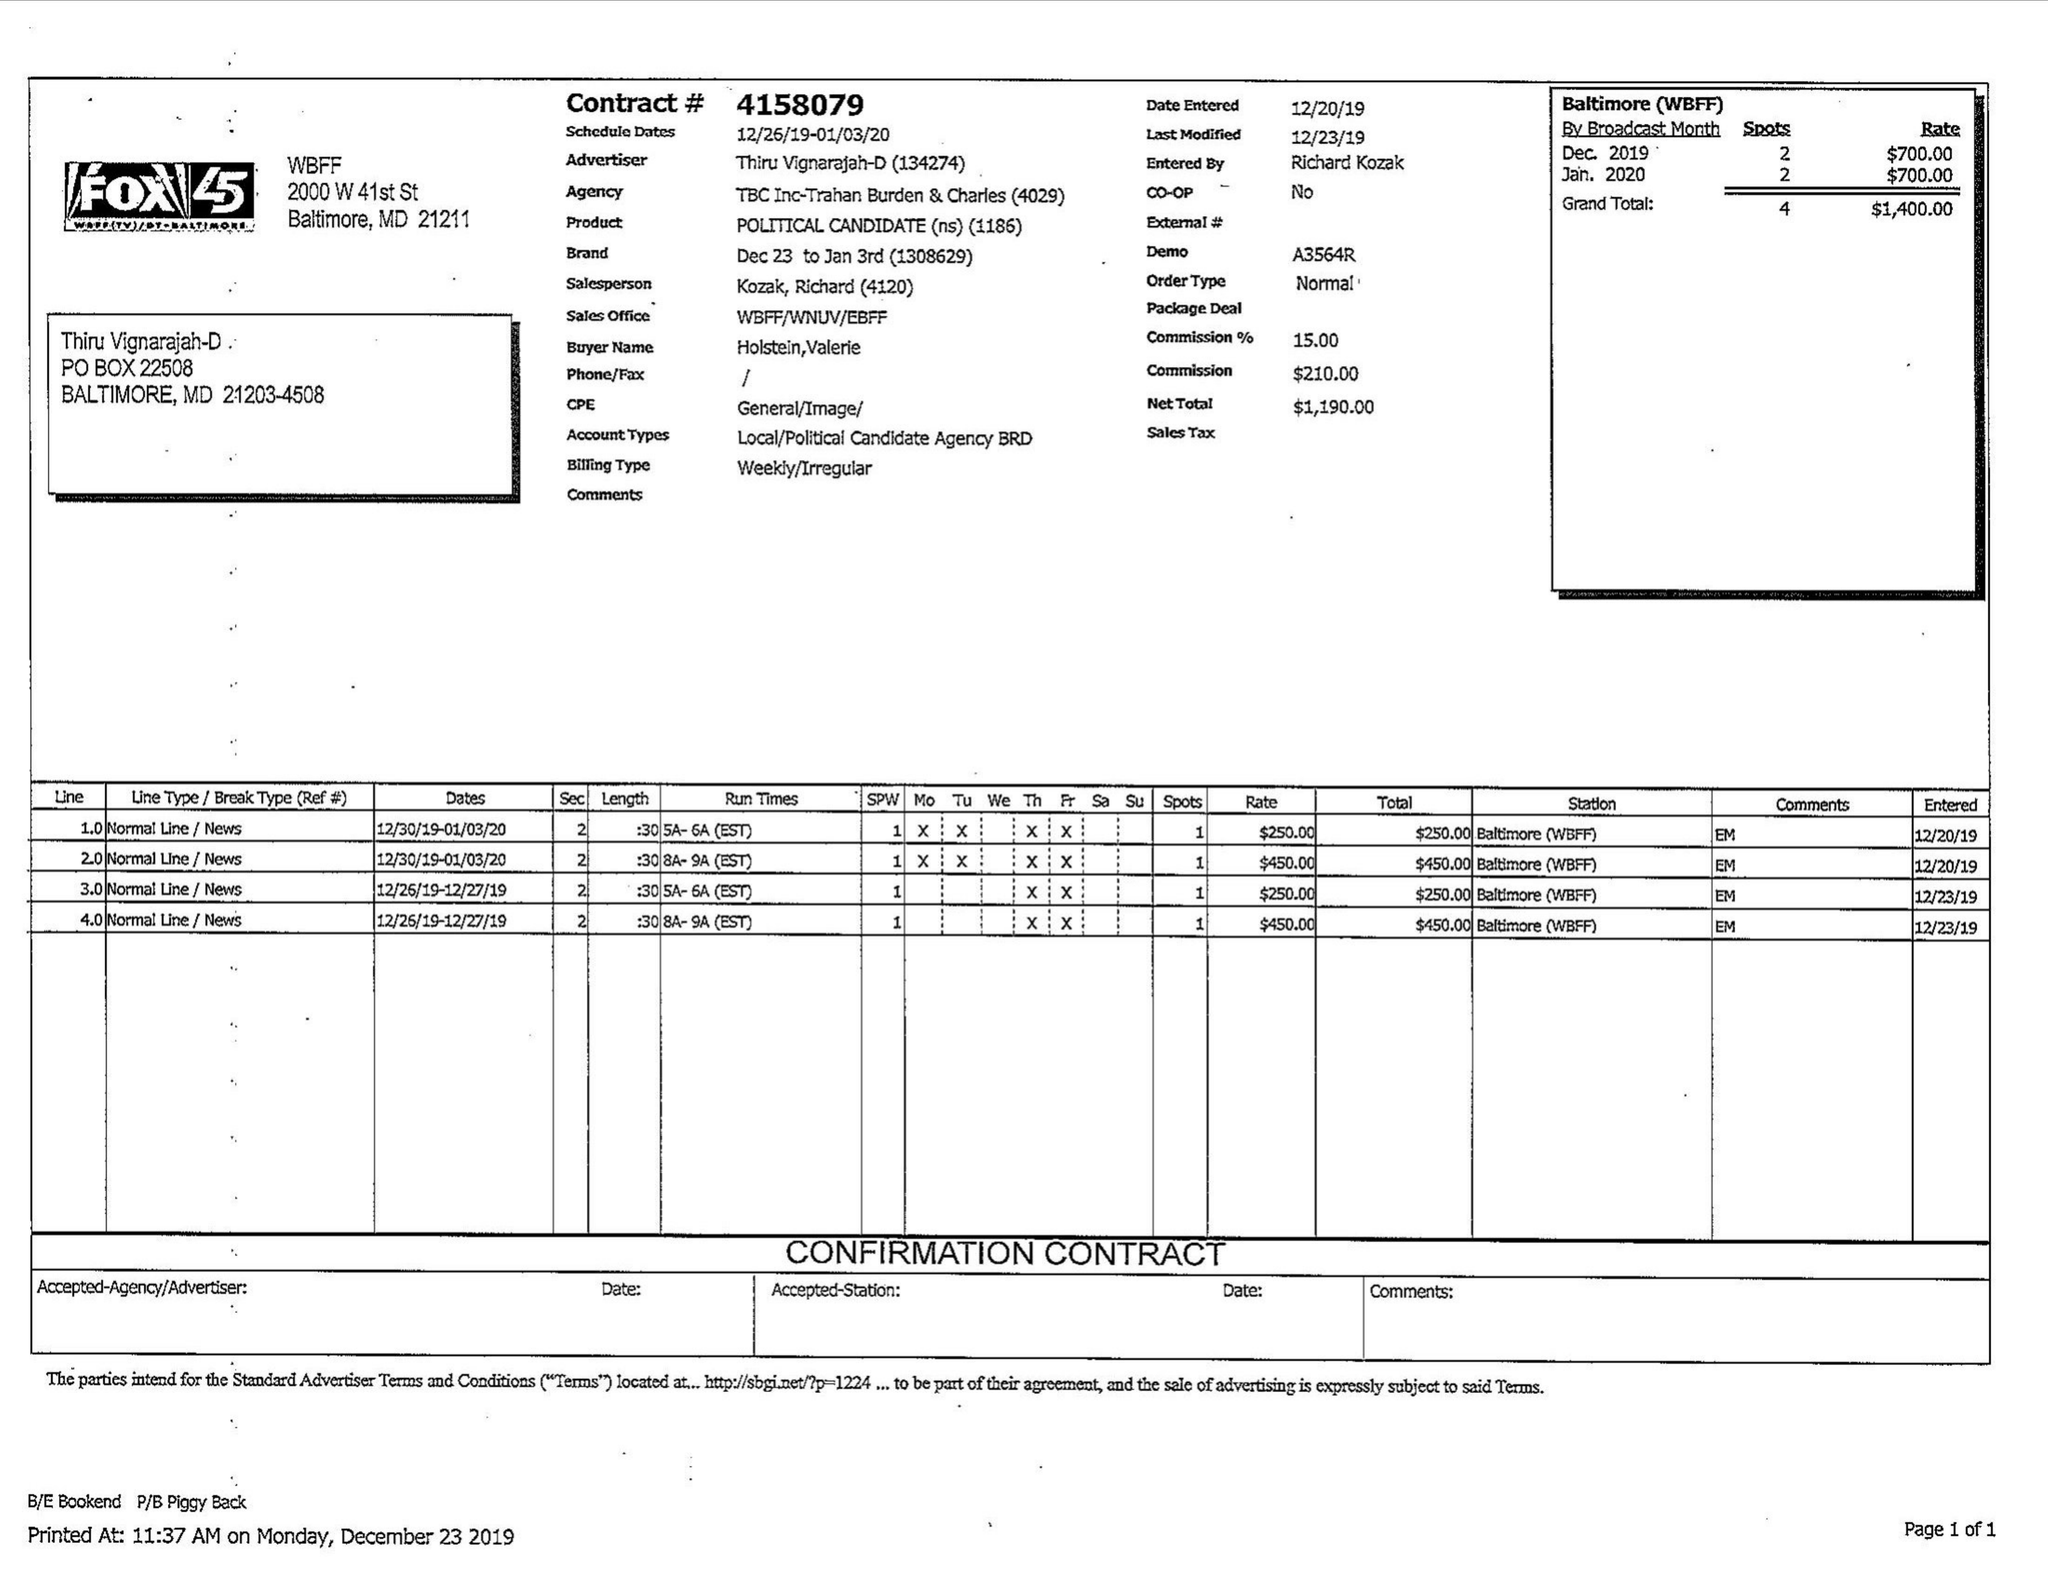What is the value for the contract_num?
Answer the question using a single word or phrase. 4158079 